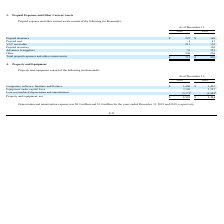From Neonode's financial document, How much were the depreciation and amortization expenses for the years ended December 31, 2018, and 2019, respectively? The document shows two values: $1.0 million and $0.9 million. From the document: "Depreciation and amortization expense was $0.9 million and $1.0 million for the years ended December 31, 2019 and 2018, respectively. tion and amortiz..." Also, What is the net value of property and equipment as of December 31, 2019, and 2018, respectively?  The document shows two values: $1,583 and $2,484 (in thousands). From the document: "Property and equipment, net $ 1,583 $ 2,484 Property and equipment, net $ 1,583 $ 2,484..." Also, What is the value of equipment under capital lease as of December 31, 2019? According to the financial document, 3,348 (in thousands). The relevant text states: "Equipment under capital lease 3,348 3,525..." Also, can you calculate: What is the ratio of depreciation and amortization expense for the year 2018 to 2019? Based on the calculation: 1/0.9 , the result is 1.11. This is based on the information: "Depreciation and amortization expense was $0.9 million and $1.0 million for the years ended December 31, 2019 and 2018, respectively. As of December 31,..." The key data points involved are: 0.9. Also, can you calculate: What is the percentage change in computers, software, furniture and fixtures between 2018 and 2019? To answer this question, I need to perform calculations using the financial data. The calculation is: ($1,406-$1,407)/$1,407 , which equals -0.07 (percentage). This is based on the information: "Computers, software, furniture and fixtures $ 1,406 $ 1,407 uters, software, furniture and fixtures $ 1,406 $ 1,407..." The key data points involved are: 1,406, 1,407. Also, can you calculate: What is the percentage change in the net value of property and equipment between 2018 and 2019? To answer this question, I need to perform calculations using the financial data. The calculation is: ($1,583-$2,484)/$2,484 , which equals -36.27 (percentage). This is based on the information: "Property and equipment, net $ 1,583 $ 2,484 Property and equipment, net $ 1,583 $ 2,484..." The key data points involved are: 1,583, 2,484. 